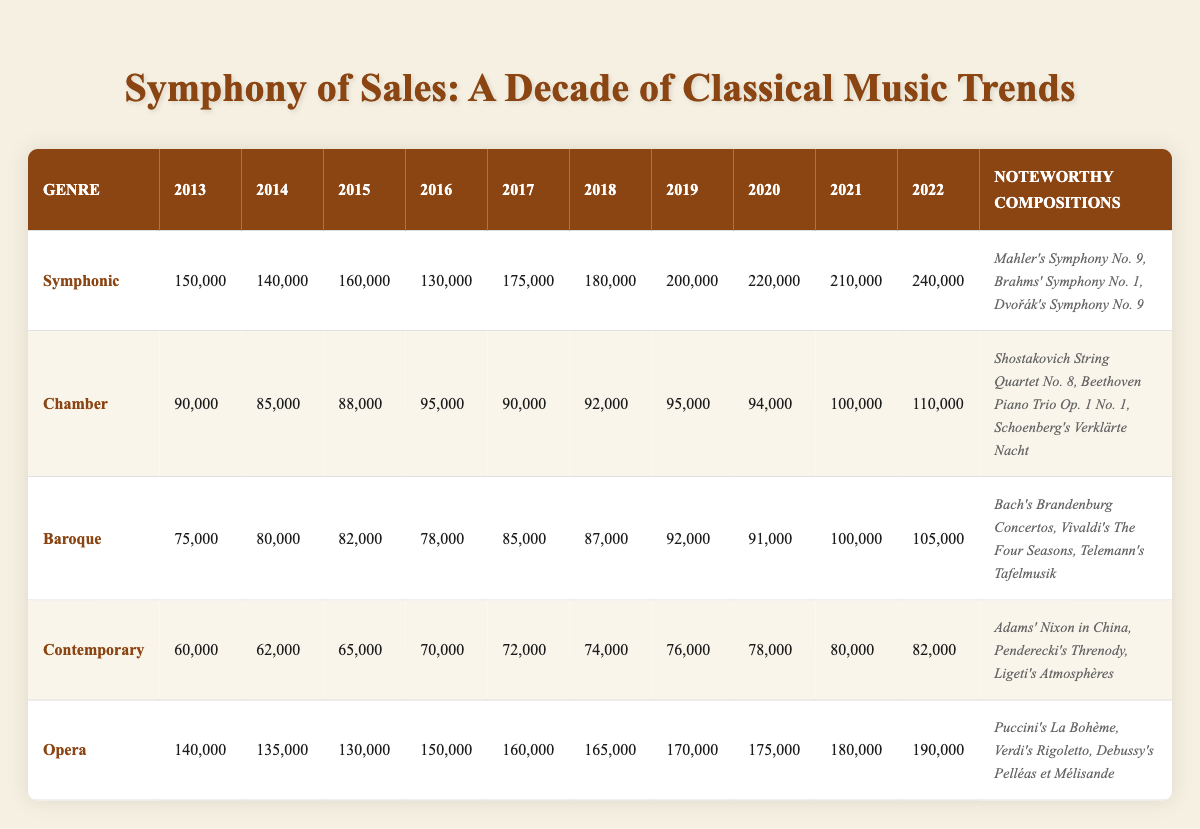What was the highest sales unit for the Symphonic genre over the decade? I look at the Symphonic row and find the maximum value in the sales units. The values are 150000, 140000, 160000, 130000, 175000, 180000, 200000, 220000, 210000, and 240000. The highest value is 240000 in 2022.
Answer: 240000 Which genre had the lowest sales in 2013? By examining the sales data for 2013, I find the values for each genre: Symphonic (150000), Chamber (90000), Baroque (75000), Contemporary (60000), and Opera (140000). The lowest value among these is 60000 for the Contemporary genre.
Answer: Contemporary What is the total sales difference between the highest and lowest selling genres in 2022? In 2022, the sales units are: Symphonic (240000), Chamber (110000), Baroque (105000), Contemporary (82000), and Opera (190000). The highest is 240000 (Symphonic) and the lowest is 82000 (Contemporary). The difference is 240000 - 82000 = 158000.
Answer: 158000 Did the Chamber genre ever exceed 100000 in sales units? Checking the sales figures for the Chamber genre: 90000, 85000, 88000, 95000, 90000, 92000, 95000, 94000, 100000, and 110000, I see that it only reached 100000 and above in the years 2021 and 2022, confirming it did exceed 100000 in those years.
Answer: Yes What is the average sales unit for the Opera genre over the last decade? To find the average for the Opera genre, I sum its sales units: 140000 + 135000 + 130000 + 150000 + 160000 + 165000 + 170000 + 175000 + 180000 + 190000 = 1415000. There are 10 data points, so the average is 1415000 / 10 = 141500.
Answer: 141500 How many genres had sales units above 100000 in 2021? From the 2021 sales units: Symphonic (210000), Chamber (100000), Baroque (100000), Contemporary (80000), and Opera (180000), I see that only Symphonic and Opera had sales above 100000, which totals to 3 genres since Chamber matches but doesn’t exceed.
Answer: 3 